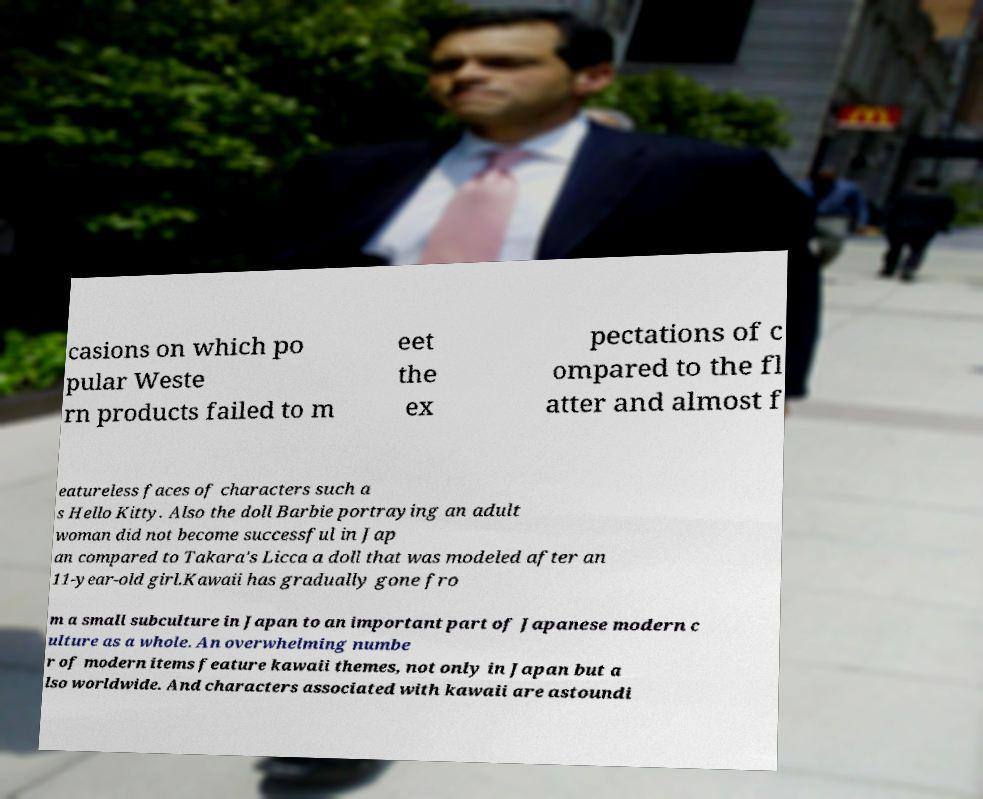Could you assist in decoding the text presented in this image and type it out clearly? casions on which po pular Weste rn products failed to m eet the ex pectations of c ompared to the fl atter and almost f eatureless faces of characters such a s Hello Kitty. Also the doll Barbie portraying an adult woman did not become successful in Jap an compared to Takara's Licca a doll that was modeled after an 11-year-old girl.Kawaii has gradually gone fro m a small subculture in Japan to an important part of Japanese modern c ulture as a whole. An overwhelming numbe r of modern items feature kawaii themes, not only in Japan but a lso worldwide. And characters associated with kawaii are astoundi 